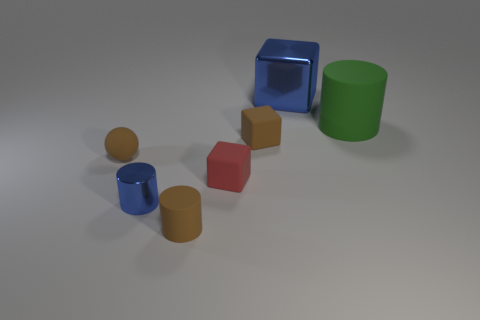Add 3 brown cylinders. How many objects exist? 10 Subtract all small blue cylinders. How many cylinders are left? 2 Subtract all cubes. How many objects are left? 4 Subtract all cyan blocks. Subtract all blue cylinders. How many blocks are left? 3 Subtract all green balls. How many red blocks are left? 1 Subtract all big blocks. Subtract all small red cubes. How many objects are left? 5 Add 7 big objects. How many big objects are left? 9 Add 5 big objects. How many big objects exist? 7 Subtract all red cubes. How many cubes are left? 2 Subtract 0 green spheres. How many objects are left? 7 